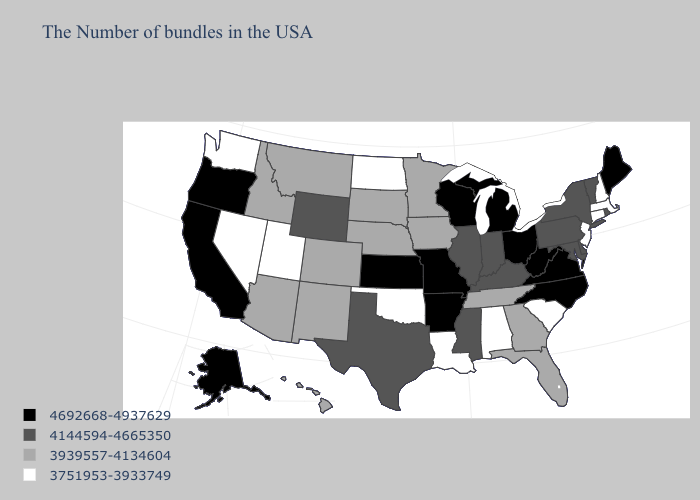Name the states that have a value in the range 3751953-3933749?
Be succinct. Massachusetts, New Hampshire, Connecticut, New Jersey, South Carolina, Alabama, Louisiana, Oklahoma, North Dakota, Utah, Nevada, Washington. Among the states that border Iowa , which have the highest value?
Quick response, please. Wisconsin, Missouri. Does New York have the highest value in the USA?
Keep it brief. No. What is the value of Connecticut?
Answer briefly. 3751953-3933749. Does New Hampshire have a lower value than Oklahoma?
Give a very brief answer. No. Does Tennessee have the same value as Iowa?
Write a very short answer. Yes. Name the states that have a value in the range 3751953-3933749?
Concise answer only. Massachusetts, New Hampshire, Connecticut, New Jersey, South Carolina, Alabama, Louisiana, Oklahoma, North Dakota, Utah, Nevada, Washington. What is the value of Missouri?
Be succinct. 4692668-4937629. Among the states that border Kansas , which have the highest value?
Be succinct. Missouri. What is the highest value in the USA?
Quick response, please. 4692668-4937629. What is the lowest value in states that border New Jersey?
Give a very brief answer. 4144594-4665350. Is the legend a continuous bar?
Keep it brief. No. What is the lowest value in states that border Arizona?
Keep it brief. 3751953-3933749. Among the states that border Indiana , which have the lowest value?
Concise answer only. Kentucky, Illinois. Among the states that border North Carolina , which have the lowest value?
Give a very brief answer. South Carolina. 